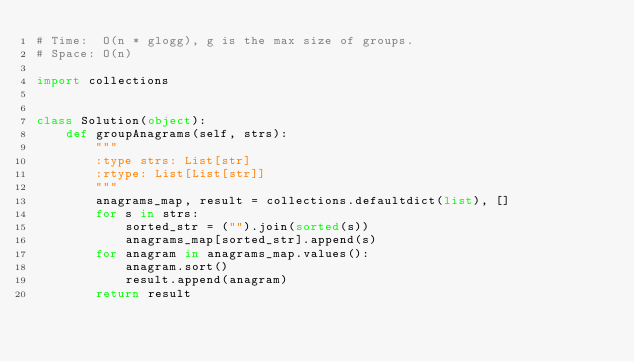<code> <loc_0><loc_0><loc_500><loc_500><_Python_># Time:  O(n * glogg), g is the max size of groups.
# Space: O(n)

import collections


class Solution(object):
    def groupAnagrams(self, strs):
        """
        :type strs: List[str]
        :rtype: List[List[str]]
        """
        anagrams_map, result = collections.defaultdict(list), []
        for s in strs:
            sorted_str = ("").join(sorted(s))
            anagrams_map[sorted_str].append(s)
        for anagram in anagrams_map.values():
            anagram.sort()
            result.append(anagram)
        return result


</code> 